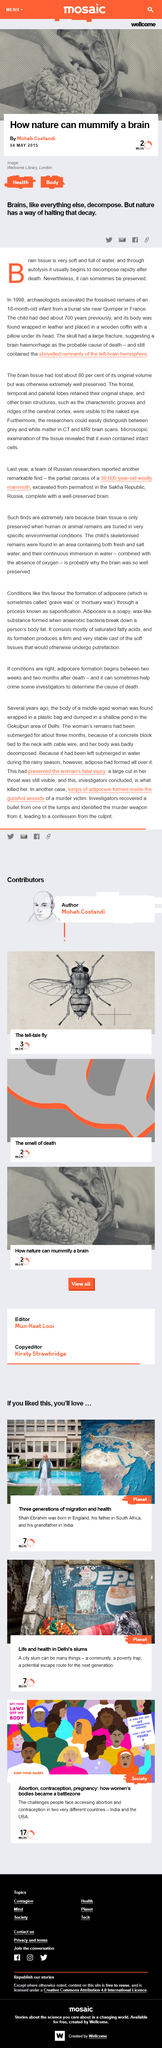Give some essential details in this illustration. Archaeologists excavated an 18-month-old infant in 1998. The article was published on May 4th, 2015. The article "How nature can mummify a brain" was written by Moheb Costandi. 